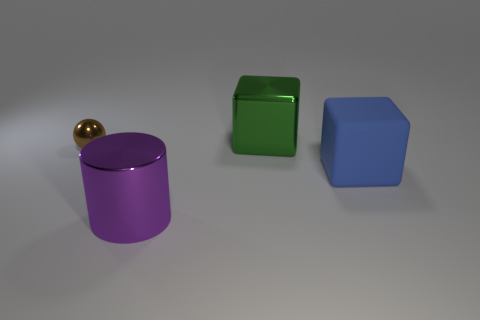Can you describe the lighting in the scene? The scene is lit from above, as indicated by the soft shadows cast directly underneath the objects. The lighting appears diffuse, with no harsh shadows or bright highlights, which results in a very even illumination across the entire scene, giving each object a gentle gradient of light to dark. 